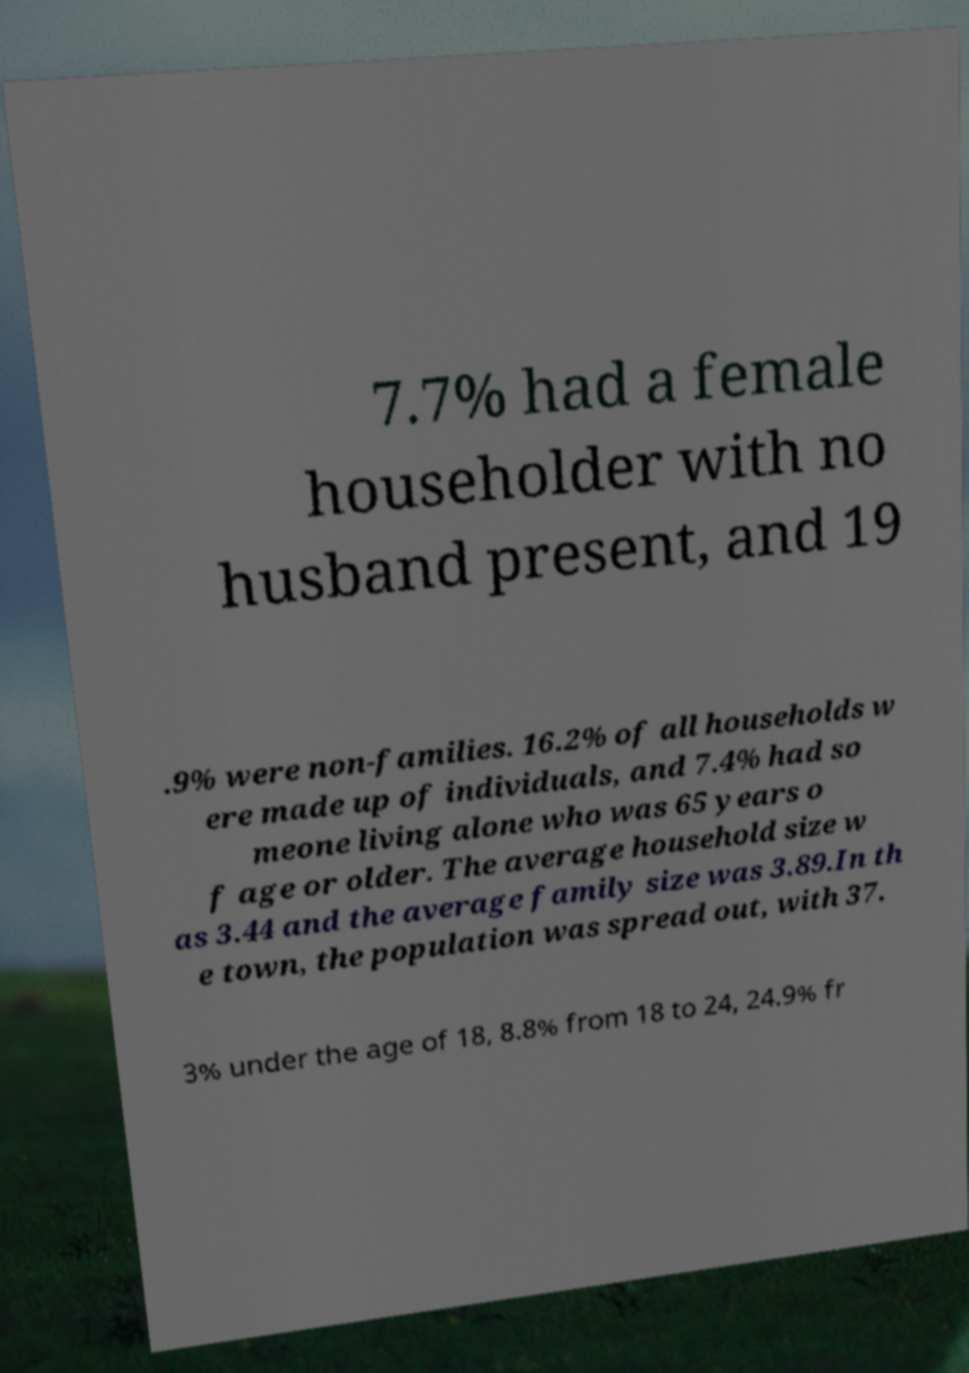Can you read and provide the text displayed in the image?This photo seems to have some interesting text. Can you extract and type it out for me? 7.7% had a female householder with no husband present, and 19 .9% were non-families. 16.2% of all households w ere made up of individuals, and 7.4% had so meone living alone who was 65 years o f age or older. The average household size w as 3.44 and the average family size was 3.89.In th e town, the population was spread out, with 37. 3% under the age of 18, 8.8% from 18 to 24, 24.9% fr 